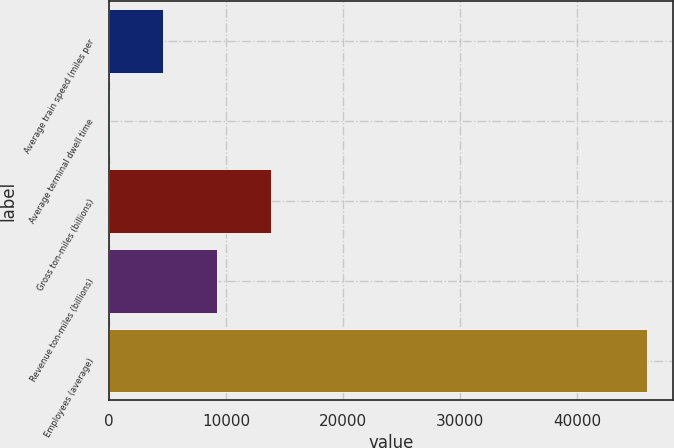Convert chart. <chart><loc_0><loc_0><loc_500><loc_500><bar_chart><fcel>Average train speed (miles per<fcel>Average terminal dwell time<fcel>Gross ton-miles (billions)<fcel>Revenue ton-miles (billions)<fcel>Employees (average)<nl><fcel>4616.38<fcel>26.2<fcel>13796.7<fcel>9206.56<fcel>45928<nl></chart> 